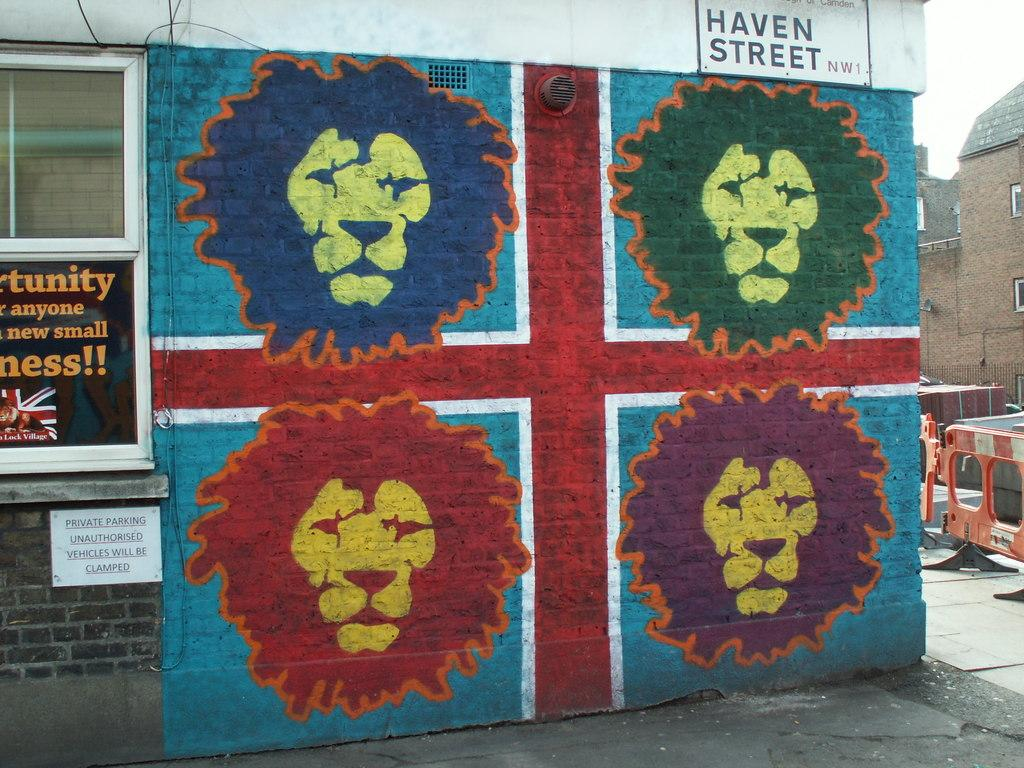<image>
Provide a brief description of the given image. Graphics with different colored lion faces are below a sign for Haven Street. 